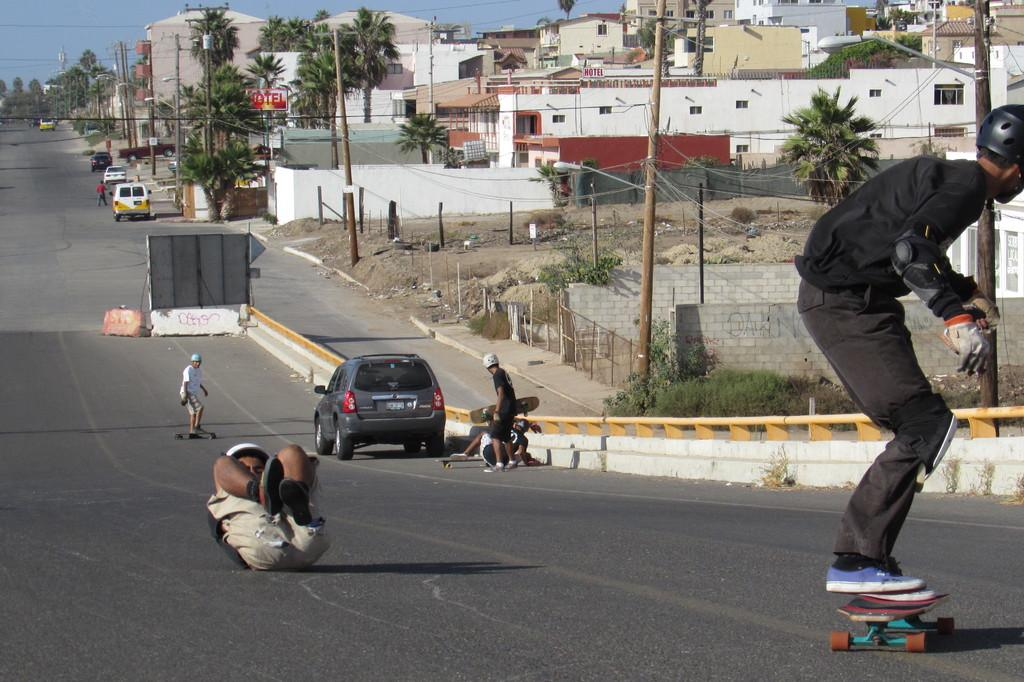What is the main feature of the image? There is a road in the image. What are the people on the road doing? People are skating on the road. Are there any vehicles in the image? Yes, there are vehicles parked in the image. What can be seen in the background of the image? There are houses and trees in the background of the image. What type of cakes are being served at the event in the image? There is no event or cakes present in the image; it features a road with people skating and parked vehicles. What idea does the alarm in the image represent? There is no alarm present in the image. 